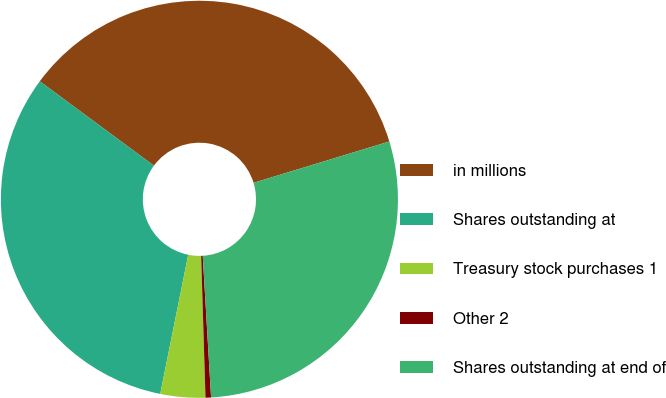<chart> <loc_0><loc_0><loc_500><loc_500><pie_chart><fcel>in millions<fcel>Shares outstanding at<fcel>Treasury stock purchases 1<fcel>Other 2<fcel>Shares outstanding at end of<nl><fcel>35.17%<fcel>31.97%<fcel>3.65%<fcel>0.45%<fcel>28.77%<nl></chart> 